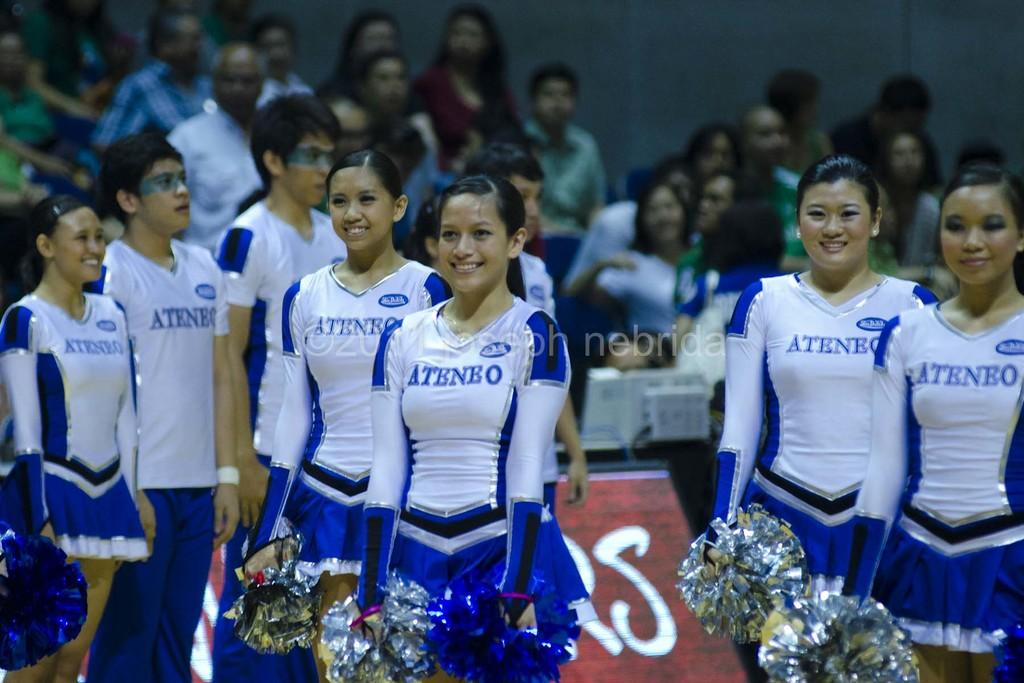<image>
Create a compact narrative representing the image presented. A cheerleading team with "Ateneo" written on their uniforms. 